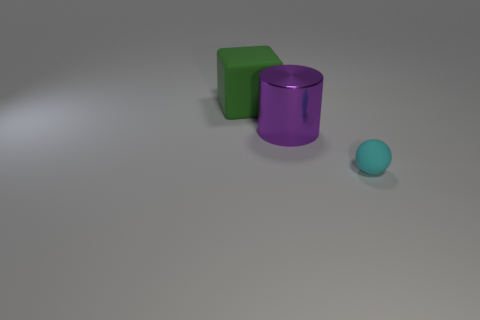Add 3 large green metal cubes. How many objects exist? 6 Subtract all spheres. How many objects are left? 2 Subtract 0 gray blocks. How many objects are left? 3 Subtract all green things. Subtract all large purple blocks. How many objects are left? 2 Add 3 large metallic objects. How many large metallic objects are left? 4 Add 3 tiny cyan matte objects. How many tiny cyan matte objects exist? 4 